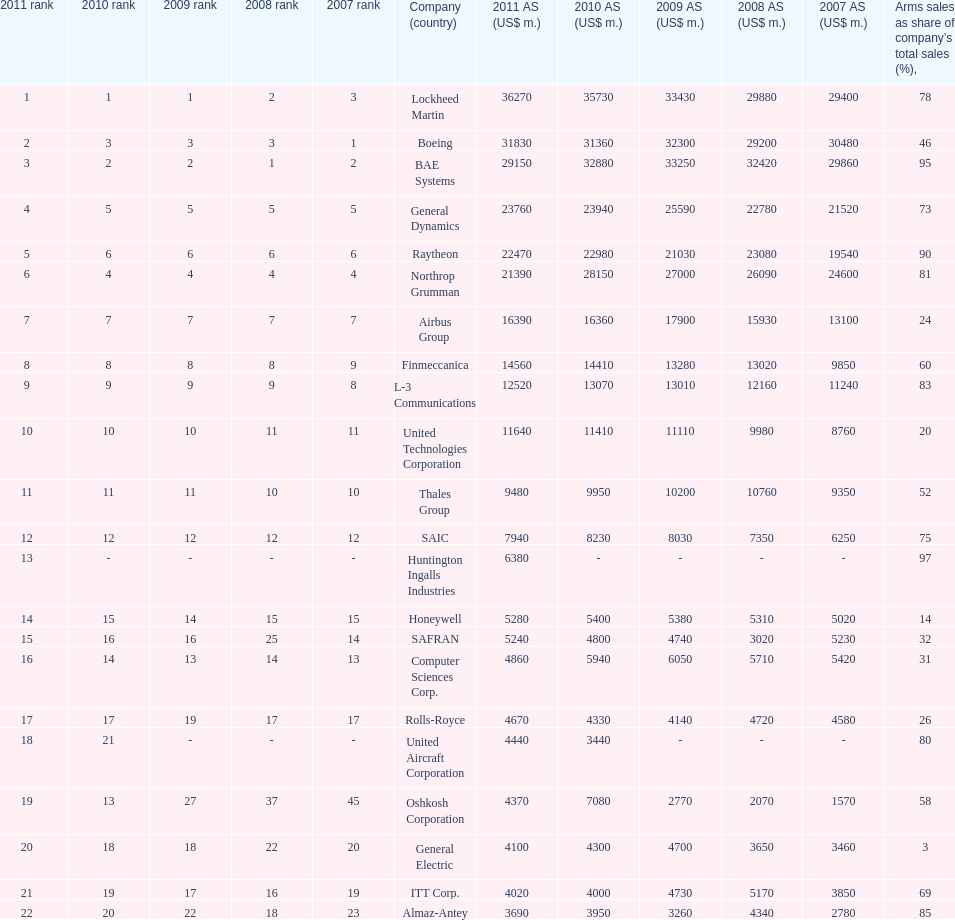What is the difference of the amount sold between boeing and general dynamics in 2007? 8960. 